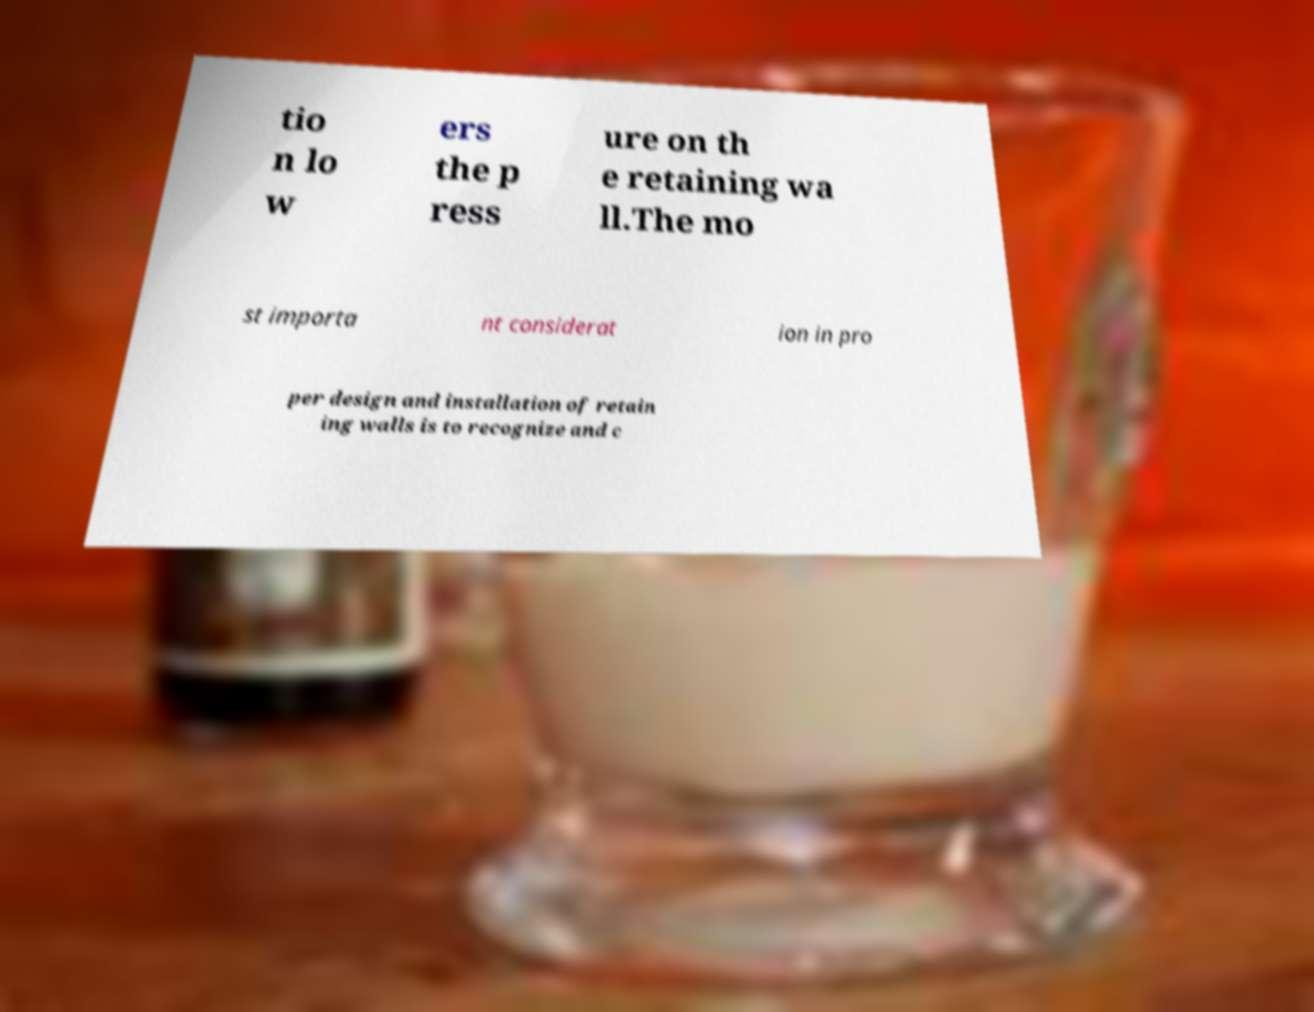Could you extract and type out the text from this image? tio n lo w ers the p ress ure on th e retaining wa ll.The mo st importa nt considerat ion in pro per design and installation of retain ing walls is to recognize and c 